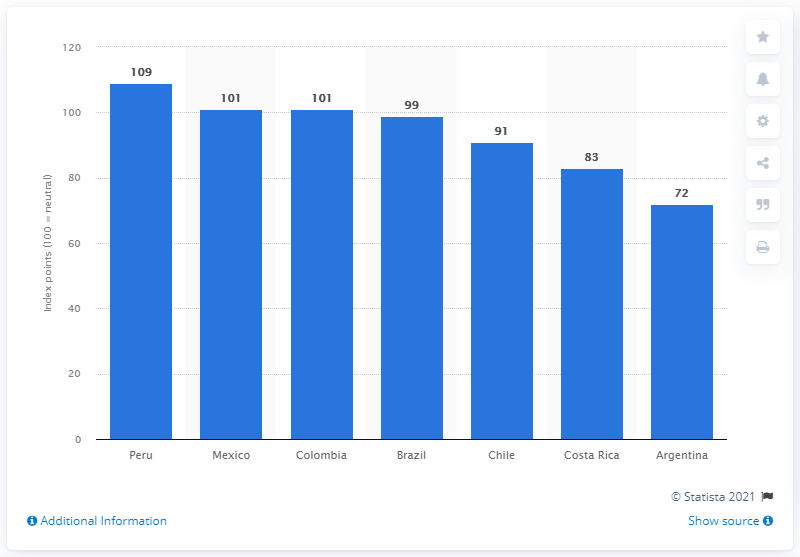Give some essential details in this illustration. Argentina had the lowest value of the consumer confidence index among all countries, according to the latest data. In the first quarter of 2019, the consumer confidence index in Peru was 109. 